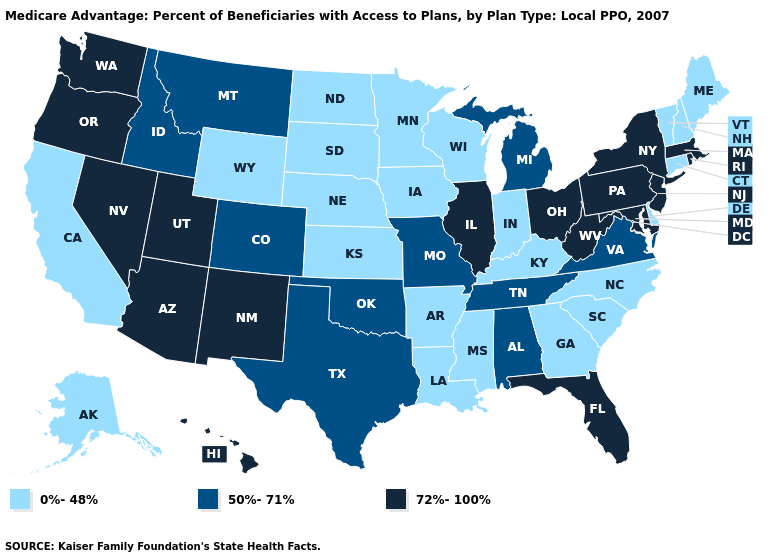Name the states that have a value in the range 0%-48%?
Answer briefly. Alaska, Arkansas, California, Connecticut, Delaware, Georgia, Iowa, Indiana, Kansas, Kentucky, Louisiana, Maine, Minnesota, Mississippi, North Carolina, North Dakota, Nebraska, New Hampshire, South Carolina, South Dakota, Vermont, Wisconsin, Wyoming. Name the states that have a value in the range 72%-100%?
Write a very short answer. Arizona, Florida, Hawaii, Illinois, Massachusetts, Maryland, New Jersey, New Mexico, Nevada, New York, Ohio, Oregon, Pennsylvania, Rhode Island, Utah, Washington, West Virginia. Which states hav the highest value in the South?
Give a very brief answer. Florida, Maryland, West Virginia. Does Pennsylvania have the highest value in the USA?
Answer briefly. Yes. What is the highest value in states that border Michigan?
Be succinct. 72%-100%. Name the states that have a value in the range 50%-71%?
Write a very short answer. Alabama, Colorado, Idaho, Michigan, Missouri, Montana, Oklahoma, Tennessee, Texas, Virginia. Among the states that border Florida , does Alabama have the lowest value?
Keep it brief. No. Does the map have missing data?
Give a very brief answer. No. Name the states that have a value in the range 0%-48%?
Concise answer only. Alaska, Arkansas, California, Connecticut, Delaware, Georgia, Iowa, Indiana, Kansas, Kentucky, Louisiana, Maine, Minnesota, Mississippi, North Carolina, North Dakota, Nebraska, New Hampshire, South Carolina, South Dakota, Vermont, Wisconsin, Wyoming. How many symbols are there in the legend?
Concise answer only. 3. Name the states that have a value in the range 72%-100%?
Give a very brief answer. Arizona, Florida, Hawaii, Illinois, Massachusetts, Maryland, New Jersey, New Mexico, Nevada, New York, Ohio, Oregon, Pennsylvania, Rhode Island, Utah, Washington, West Virginia. Name the states that have a value in the range 50%-71%?
Give a very brief answer. Alabama, Colorado, Idaho, Michigan, Missouri, Montana, Oklahoma, Tennessee, Texas, Virginia. Does Nebraska have a higher value than Rhode Island?
Write a very short answer. No. Name the states that have a value in the range 72%-100%?
Write a very short answer. Arizona, Florida, Hawaii, Illinois, Massachusetts, Maryland, New Jersey, New Mexico, Nevada, New York, Ohio, Oregon, Pennsylvania, Rhode Island, Utah, Washington, West Virginia. Does New Mexico have the highest value in the USA?
Be succinct. Yes. 